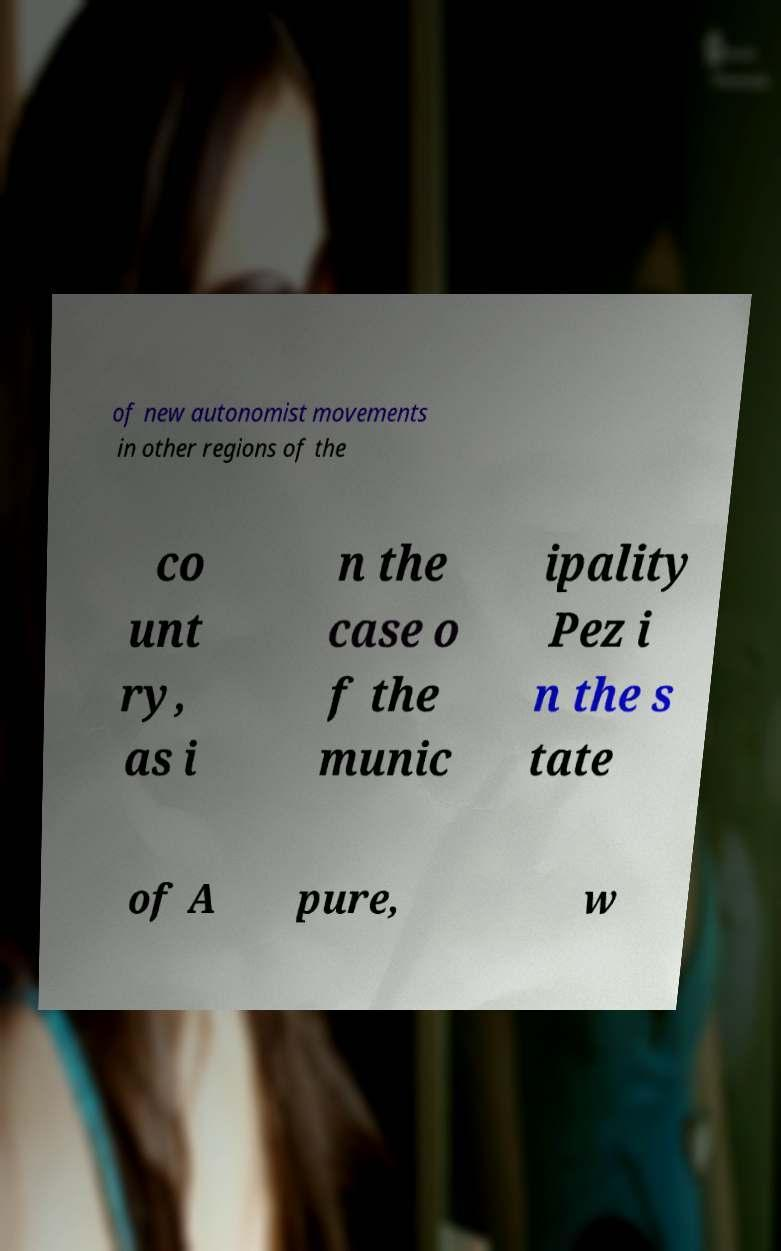I need the written content from this picture converted into text. Can you do that? of new autonomist movements in other regions of the co unt ry, as i n the case o f the munic ipality Pez i n the s tate of A pure, w 